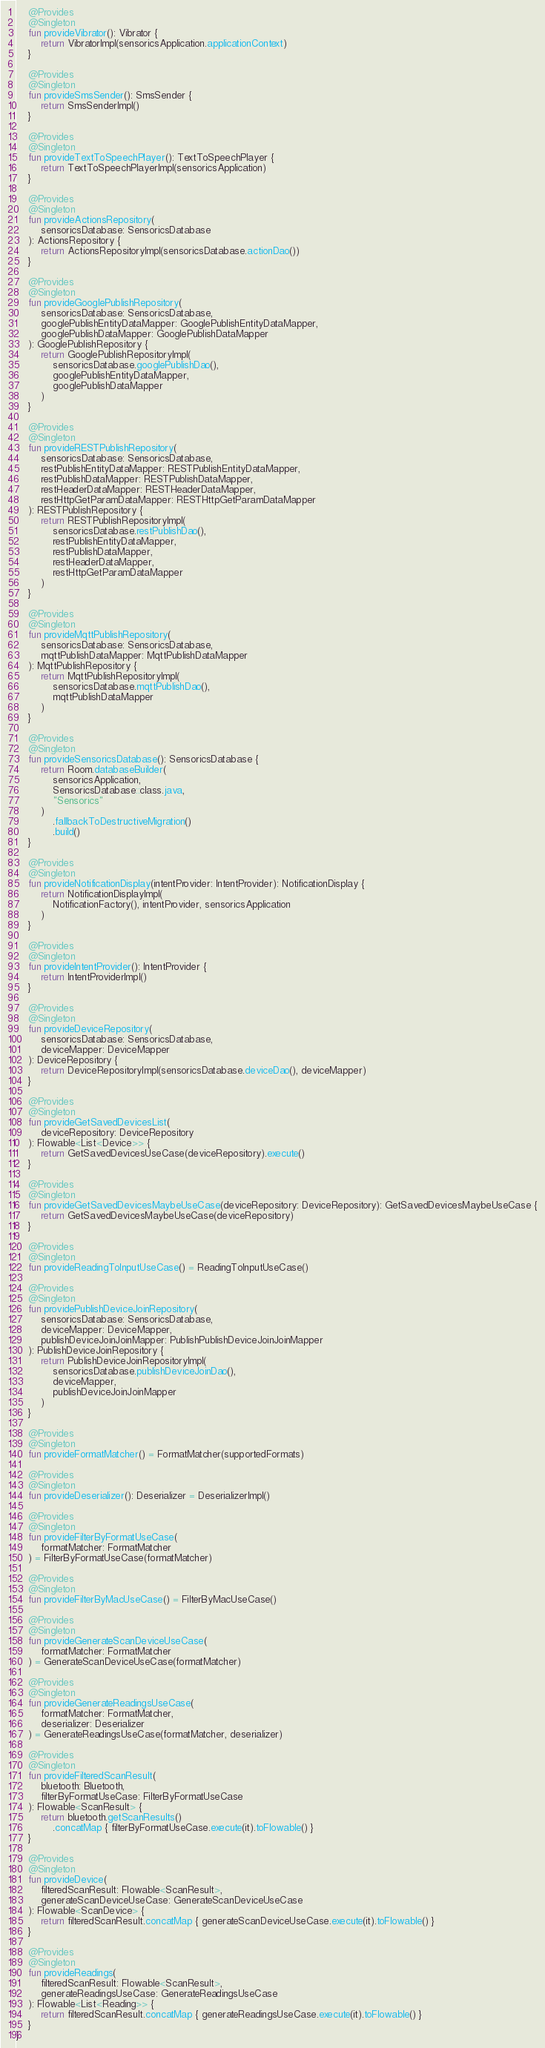<code> <loc_0><loc_0><loc_500><loc_500><_Kotlin_>
    @Provides
    @Singleton
    fun provideVibrator(): Vibrator {
        return VibratorImpl(sensoricsApplication.applicationContext)
    }

    @Provides
    @Singleton
    fun provideSmsSender(): SmsSender {
        return SmsSenderImpl()
    }

    @Provides
    @Singleton
    fun provideTextToSpeechPlayer(): TextToSpeechPlayer {
        return TextToSpeechPlayerImpl(sensoricsApplication)
    }

    @Provides
    @Singleton
    fun provideActionsRepository(
        sensoricsDatabase: SensoricsDatabase
    ): ActionsRepository {
        return ActionsRepositoryImpl(sensoricsDatabase.actionDao())
    }

    @Provides
    @Singleton
    fun provideGooglePublishRepository(
        sensoricsDatabase: SensoricsDatabase,
        googlePublishEntityDataMapper: GooglePublishEntityDataMapper,
        googlePublishDataMapper: GooglePublishDataMapper
    ): GooglePublishRepository {
        return GooglePublishRepositoryImpl(
            sensoricsDatabase.googlePublishDao(),
            googlePublishEntityDataMapper,
            googlePublishDataMapper
        )
    }

    @Provides
    @Singleton
    fun provideRESTPublishRepository(
        sensoricsDatabase: SensoricsDatabase,
        restPublishEntityDataMapper: RESTPublishEntityDataMapper,
        restPublishDataMapper: RESTPublishDataMapper,
        restHeaderDataMapper: RESTHeaderDataMapper,
        restHttpGetParamDataMapper: RESTHttpGetParamDataMapper
    ): RESTPublishRepository {
        return RESTPublishRepositoryImpl(
            sensoricsDatabase.restPublishDao(),
            restPublishEntityDataMapper,
            restPublishDataMapper,
            restHeaderDataMapper,
            restHttpGetParamDataMapper
        )
    }

    @Provides
    @Singleton
    fun provideMqttPublishRepository(
        sensoricsDatabase: SensoricsDatabase,
        mqttPublishDataMapper: MqttPublishDataMapper
    ): MqttPublishRepository {
        return MqttPublishRepositoryImpl(
            sensoricsDatabase.mqttPublishDao(),
            mqttPublishDataMapper
        )
    }

    @Provides
    @Singleton
    fun provideSensoricsDatabase(): SensoricsDatabase {
        return Room.databaseBuilder(
            sensoricsApplication,
            SensoricsDatabase::class.java,
            "Sensorics"
        )
            .fallbackToDestructiveMigration()
            .build()
    }

    @Provides
    @Singleton
    fun provideNotificationDisplay(intentProvider: IntentProvider): NotificationDisplay {
        return NotificationDisplayImpl(
            NotificationFactory(), intentProvider, sensoricsApplication
        )
    }

    @Provides
    @Singleton
    fun provideIntentProvider(): IntentProvider {
        return IntentProviderImpl()
    }

    @Provides
    @Singleton
    fun provideDeviceRepository(
        sensoricsDatabase: SensoricsDatabase,
        deviceMapper: DeviceMapper
    ): DeviceRepository {
        return DeviceRepositoryImpl(sensoricsDatabase.deviceDao(), deviceMapper)
    }

    @Provides
    @Singleton
    fun provideGetSavedDevicesList(
        deviceRepository: DeviceRepository
    ): Flowable<List<Device>> {
        return GetSavedDevicesUseCase(deviceRepository).execute()
    }

    @Provides
    @Singleton
    fun provideGetSavedDevicesMaybeUseCase(deviceRepository: DeviceRepository): GetSavedDevicesMaybeUseCase {
        return GetSavedDevicesMaybeUseCase(deviceRepository)
    }

    @Provides
    @Singleton
    fun provideReadingToInputUseCase() = ReadingToInputUseCase()

    @Provides
    @Singleton
    fun providePublishDeviceJoinRepository(
        sensoricsDatabase: SensoricsDatabase,
        deviceMapper: DeviceMapper,
        publishDeviceJoinJoinMapper: PublishPublishDeviceJoinJoinMapper
    ): PublishDeviceJoinRepository {
        return PublishDeviceJoinRepositoryImpl(
            sensoricsDatabase.publishDeviceJoinDao(),
            deviceMapper,
            publishDeviceJoinJoinMapper
        )
    }

    @Provides
    @Singleton
    fun provideFormatMatcher() = FormatMatcher(supportedFormats)

    @Provides
    @Singleton
    fun provideDeserializer(): Deserializer = DeserializerImpl()

    @Provides
    @Singleton
    fun provideFilterByFormatUseCase(
        formatMatcher: FormatMatcher
    ) = FilterByFormatUseCase(formatMatcher)

    @Provides
    @Singleton
    fun provideFilterByMacUseCase() = FilterByMacUseCase()

    @Provides
    @Singleton
    fun provideGenerateScanDeviceUseCase(
        formatMatcher: FormatMatcher
    ) = GenerateScanDeviceUseCase(formatMatcher)

    @Provides
    @Singleton
    fun provideGenerateReadingsUseCase(
        formatMatcher: FormatMatcher,
        deserializer: Deserializer
    ) = GenerateReadingsUseCase(formatMatcher, deserializer)

    @Provides
    @Singleton
    fun provideFilteredScanResult(
        bluetooth: Bluetooth,
        filterByFormatUseCase: FilterByFormatUseCase
    ): Flowable<ScanResult> {
        return bluetooth.getScanResults()
            .concatMap { filterByFormatUseCase.execute(it).toFlowable() }
    }

    @Provides
    @Singleton
    fun provideDevice(
        filteredScanResult: Flowable<ScanResult>,
        generateScanDeviceUseCase: GenerateScanDeviceUseCase
    ): Flowable<ScanDevice> {
        return filteredScanResult.concatMap { generateScanDeviceUseCase.execute(it).toFlowable() }
    }

    @Provides
    @Singleton
    fun provideReadings(
        filteredScanResult: Flowable<ScanResult>,
        generateReadingsUseCase: GenerateReadingsUseCase
    ): Flowable<List<Reading>> {
        return filteredScanResult.concatMap { generateReadingsUseCase.execute(it).toFlowable() }
    }
}</code> 